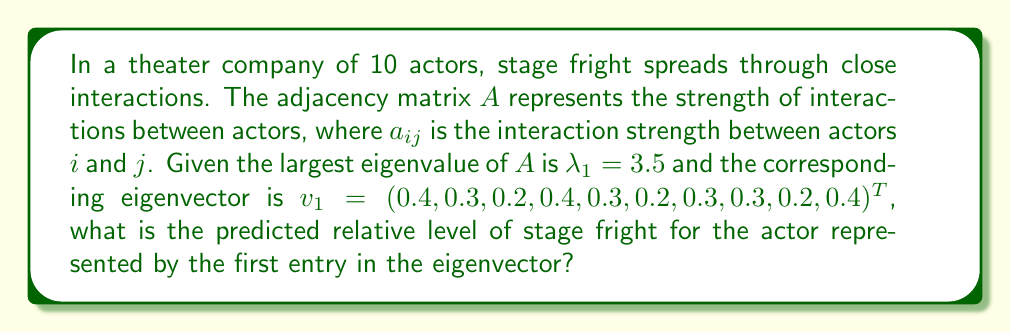Help me with this question. To solve this problem, we'll use concepts from spectral graph theory:

1) The adjacency matrix $A$ represents the network of interactions in the theater company.

2) The largest eigenvalue $\lambda_1$ (also called the spectral radius) and its corresponding eigenvector $v_1$ provide information about the spread of stage fright in the network.

3) The entries of the principal eigenvector $v_1$ correspond to the relative levels of stage fright for each actor in the long-term equilibrium state.

4) The actor with the highest entry in $v_1$ is predicted to have the highest level of stage fright in the long run.

5) In this case, we're asked about the actor represented by the first entry in the eigenvector.

6) The first entry in $v_1$ is 0.4, which is also the highest value in the vector.

7) To express this as a relative level, we can normalize it by dividing by the sum of all entries in $v_1$:

   $$\text{Relative level} = \frac{0.4}{\sum_{i=1}^{10} v_{1i}} = \frac{0.4}{3}$$

8) Simplifying:
   
   $$\frac{0.4}{3} = \frac{4}{30} \approx 0.1333$$

Therefore, the predicted relative level of stage fright for the actor represented by the first entry is approximately 0.1333 or 13.33% of the total stage fright in the company.
Answer: 0.1333 